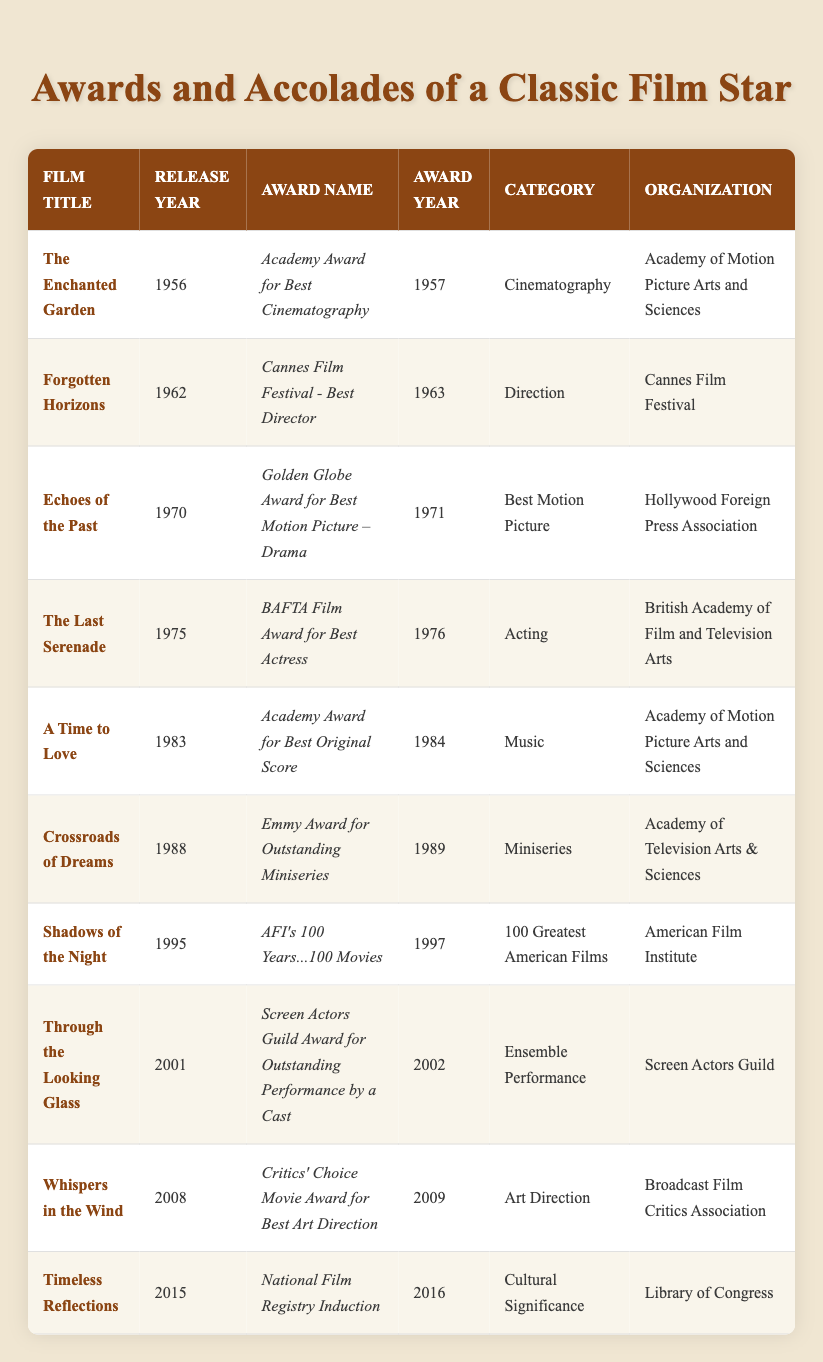What award did "The Last Serenade" win? The table shows that "The Last Serenade" won the "BAFTA Film Award for Best Actress" in 1976
Answer: BAFTA Film Award for Best Actress In what year was "Echoes of the Past" released? The release year for "Echoes of the Past" is listed in the table as 1970
Answer: 1970 How many awards did my parent's films win in the 1980s? The table lists two awards won in the 1980s: one for "A Time to Love" in 1984 and one for "Crossroads of Dreams" in 1989. Therefore, there are a total of 2 awards
Answer: 2 Which film received an award for Best Art Direction? According to the table, "Whispers in the Wind" received the "Critics' Choice Movie Award for Best Art Direction" in 2009
Answer: Whispers in the Wind Did any films from the 2000s win an Academy Award? The only film from the 2000s listed is "A Time to Love," which won an Academy Award in 1984 and does not count. Therefore, no films from the 2000s won an Academy Award
Answer: No What is the most recent film listed in the table, and what award did it receive? The most recent film is "Timeless Reflections," released in 2015. It received the "National Film Registry Induction" award in 2016
Answer: Timeless Reflections; National Film Registry Induction Which organization awarded the "Golden Globe Award for Best Motion Picture – Drama"? The organization that awarded this is the "Hollywood Foreign Press Association" according to the table
Answer: Hollywood Foreign Press Association How many different organizations awarded accolades to my parent's films across the decades? By reviewing the unique organizations listed in the table, we find 7 distinct organizations: Academy of Motion Picture Arts and Sciences, Cannes Film Festival, Hollywood Foreign Press Association, British Academy of Film and Television Arts, Academy of Television Arts & Sciences, American Film Institute, and Library of Congress
Answer: 7 Which film won an award for Cinematography, and what was it? The table indicates that "The Enchanted Garden" won the "Academy Award for Best Cinematography" in 1957
Answer: The Enchanted Garden; Academy Award for Best Cinematography What film had the earliest release year, and what award did it receive? The earliest release year in the table is 1956 for "The Enchanted Garden," which won the "Academy Award for Best Cinematography"
Answer: The Enchanted Garden; Academy Award for Best Cinematography 